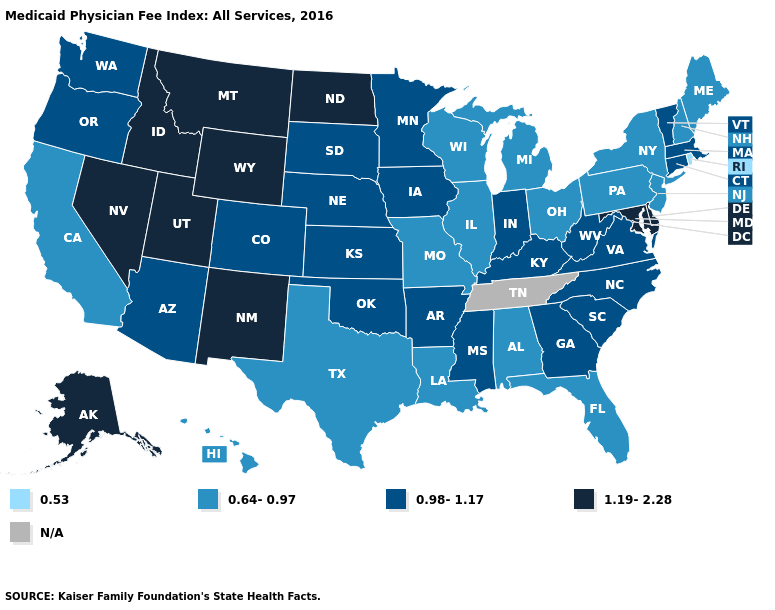Does the map have missing data?
Short answer required. Yes. Does North Dakota have the highest value in the MidWest?
Concise answer only. Yes. Among the states that border New Mexico , does Utah have the lowest value?
Write a very short answer. No. Among the states that border Delaware , which have the highest value?
Write a very short answer. Maryland. What is the highest value in the West ?
Write a very short answer. 1.19-2.28. Name the states that have a value in the range 1.19-2.28?
Keep it brief. Alaska, Delaware, Idaho, Maryland, Montana, Nevada, New Mexico, North Dakota, Utah, Wyoming. Name the states that have a value in the range 0.64-0.97?
Concise answer only. Alabama, California, Florida, Hawaii, Illinois, Louisiana, Maine, Michigan, Missouri, New Hampshire, New Jersey, New York, Ohio, Pennsylvania, Texas, Wisconsin. What is the lowest value in the MidWest?
Write a very short answer. 0.64-0.97. Among the states that border North Carolina , which have the lowest value?
Answer briefly. Georgia, South Carolina, Virginia. What is the highest value in the USA?
Short answer required. 1.19-2.28. What is the value of Oregon?
Concise answer only. 0.98-1.17. Which states hav the highest value in the West?
Short answer required. Alaska, Idaho, Montana, Nevada, New Mexico, Utah, Wyoming. Which states have the highest value in the USA?
Be succinct. Alaska, Delaware, Idaho, Maryland, Montana, Nevada, New Mexico, North Dakota, Utah, Wyoming. 